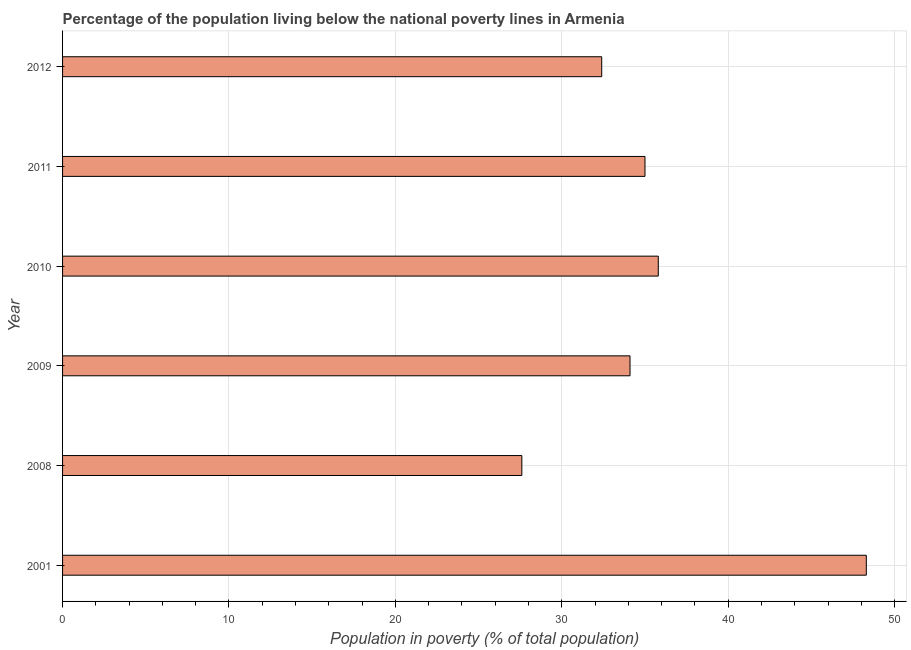What is the title of the graph?
Your answer should be compact. Percentage of the population living below the national poverty lines in Armenia. What is the label or title of the X-axis?
Offer a very short reply. Population in poverty (% of total population). What is the label or title of the Y-axis?
Your answer should be compact. Year. What is the percentage of population living below poverty line in 2001?
Your answer should be compact. 48.3. Across all years, what is the maximum percentage of population living below poverty line?
Give a very brief answer. 48.3. Across all years, what is the minimum percentage of population living below poverty line?
Make the answer very short. 27.6. In which year was the percentage of population living below poverty line maximum?
Your answer should be very brief. 2001. In which year was the percentage of population living below poverty line minimum?
Provide a succinct answer. 2008. What is the sum of the percentage of population living below poverty line?
Offer a terse response. 213.2. What is the average percentage of population living below poverty line per year?
Offer a very short reply. 35.53. What is the median percentage of population living below poverty line?
Your answer should be very brief. 34.55. Do a majority of the years between 2009 and 2011 (inclusive) have percentage of population living below poverty line greater than 40 %?
Provide a succinct answer. No. What is the ratio of the percentage of population living below poverty line in 2001 to that in 2009?
Keep it short and to the point. 1.42. Is the difference between the percentage of population living below poverty line in 2009 and 2012 greater than the difference between any two years?
Your answer should be compact. No. Is the sum of the percentage of population living below poverty line in 2009 and 2010 greater than the maximum percentage of population living below poverty line across all years?
Provide a short and direct response. Yes. What is the difference between the highest and the lowest percentage of population living below poverty line?
Provide a succinct answer. 20.7. How many bars are there?
Your response must be concise. 6. Are all the bars in the graph horizontal?
Make the answer very short. Yes. How many years are there in the graph?
Offer a very short reply. 6. Are the values on the major ticks of X-axis written in scientific E-notation?
Provide a succinct answer. No. What is the Population in poverty (% of total population) of 2001?
Offer a terse response. 48.3. What is the Population in poverty (% of total population) in 2008?
Ensure brevity in your answer.  27.6. What is the Population in poverty (% of total population) of 2009?
Provide a succinct answer. 34.1. What is the Population in poverty (% of total population) of 2010?
Keep it short and to the point. 35.8. What is the Population in poverty (% of total population) in 2012?
Your response must be concise. 32.4. What is the difference between the Population in poverty (% of total population) in 2001 and 2008?
Your answer should be very brief. 20.7. What is the difference between the Population in poverty (% of total population) in 2001 and 2009?
Your answer should be compact. 14.2. What is the difference between the Population in poverty (% of total population) in 2008 and 2010?
Ensure brevity in your answer.  -8.2. What is the difference between the Population in poverty (% of total population) in 2008 and 2011?
Your response must be concise. -7.4. What is the difference between the Population in poverty (% of total population) in 2008 and 2012?
Give a very brief answer. -4.8. What is the difference between the Population in poverty (% of total population) in 2009 and 2010?
Your answer should be compact. -1.7. What is the difference between the Population in poverty (% of total population) in 2009 and 2012?
Give a very brief answer. 1.7. What is the difference between the Population in poverty (% of total population) in 2010 and 2011?
Make the answer very short. 0.8. What is the difference between the Population in poverty (% of total population) in 2010 and 2012?
Make the answer very short. 3.4. What is the difference between the Population in poverty (% of total population) in 2011 and 2012?
Keep it short and to the point. 2.6. What is the ratio of the Population in poverty (% of total population) in 2001 to that in 2009?
Your answer should be compact. 1.42. What is the ratio of the Population in poverty (% of total population) in 2001 to that in 2010?
Provide a short and direct response. 1.35. What is the ratio of the Population in poverty (% of total population) in 2001 to that in 2011?
Your answer should be compact. 1.38. What is the ratio of the Population in poverty (% of total population) in 2001 to that in 2012?
Your response must be concise. 1.49. What is the ratio of the Population in poverty (% of total population) in 2008 to that in 2009?
Keep it short and to the point. 0.81. What is the ratio of the Population in poverty (% of total population) in 2008 to that in 2010?
Make the answer very short. 0.77. What is the ratio of the Population in poverty (% of total population) in 2008 to that in 2011?
Offer a terse response. 0.79. What is the ratio of the Population in poverty (% of total population) in 2008 to that in 2012?
Your answer should be very brief. 0.85. What is the ratio of the Population in poverty (% of total population) in 2009 to that in 2010?
Offer a very short reply. 0.95. What is the ratio of the Population in poverty (% of total population) in 2009 to that in 2012?
Your response must be concise. 1.05. What is the ratio of the Population in poverty (% of total population) in 2010 to that in 2012?
Make the answer very short. 1.1. 